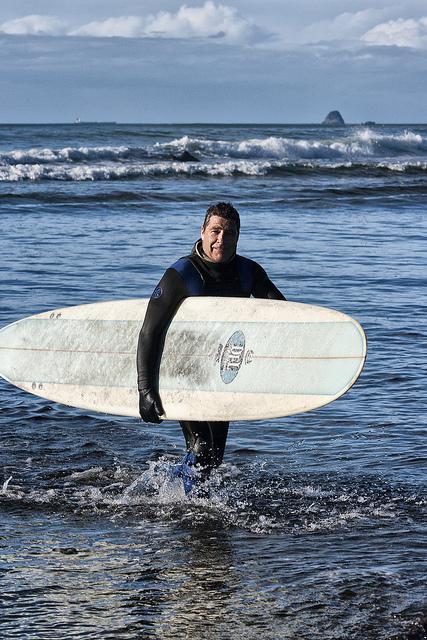How many pieces of chocolate cake are on the white plate?
Give a very brief answer. 0. 